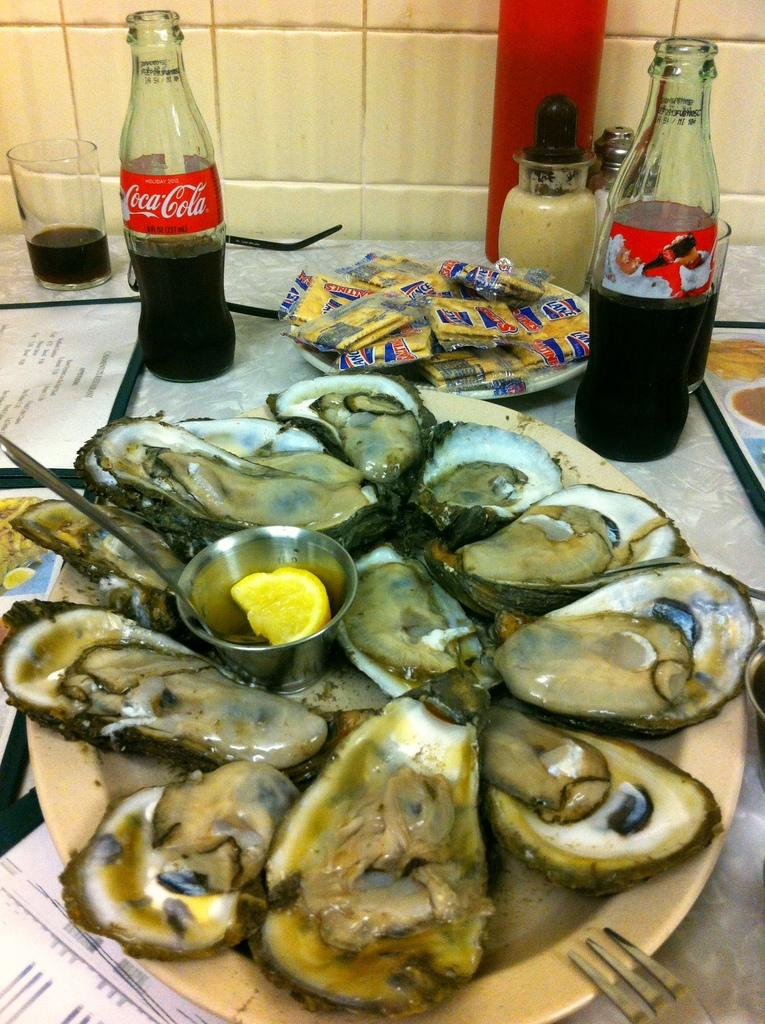What is on the plate that is visible in the image? There is a plate of food in the image. What type of beverages can be seen in the image? There are two coke bottles in the image. What can be used for drinking in the image? There are glasses in the image. What might be used for selecting items to order in the image? Menu cards are on the table in the image. What is visible in the background of the image? There is a wall in the background of the image. What type of apparatus is used to generate wind in the image? There is no apparatus for generating wind present in the image. What type of produce is visible on the plate in the image? The facts provided do not specify the type of food on the plate, so it cannot be determined from the image. 